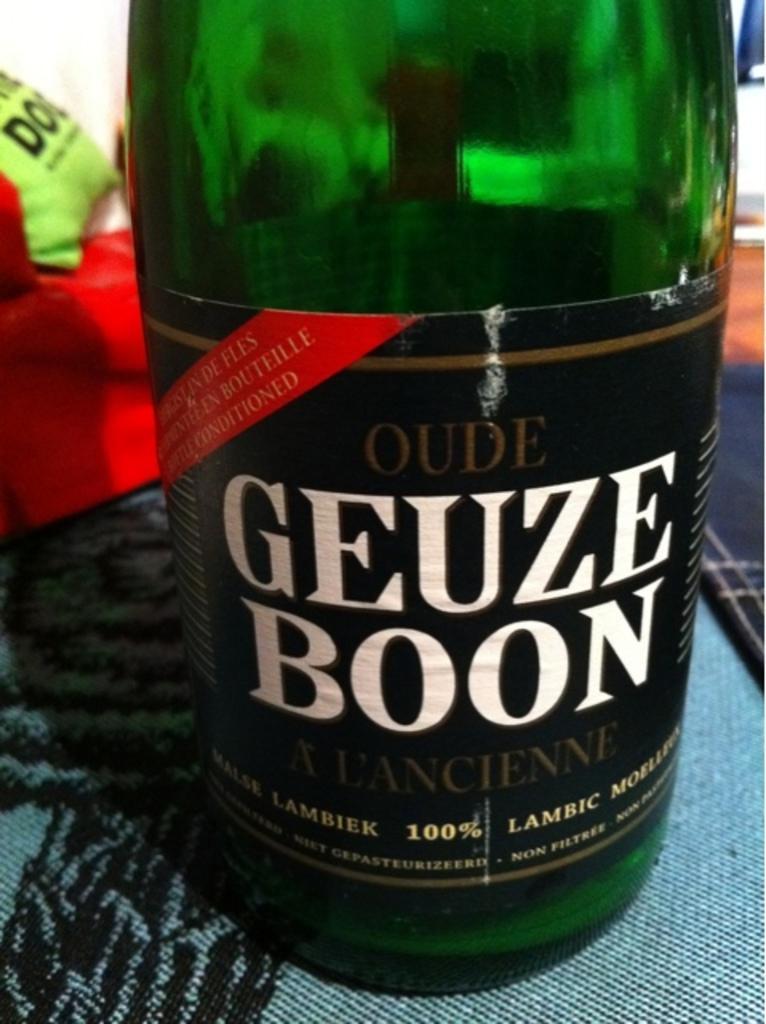Describe this image in one or two sentences. In this image, a bottle is visible half, which is kept on the floor. In the top, a red color cloth is visible. This image is taken inside a room. 